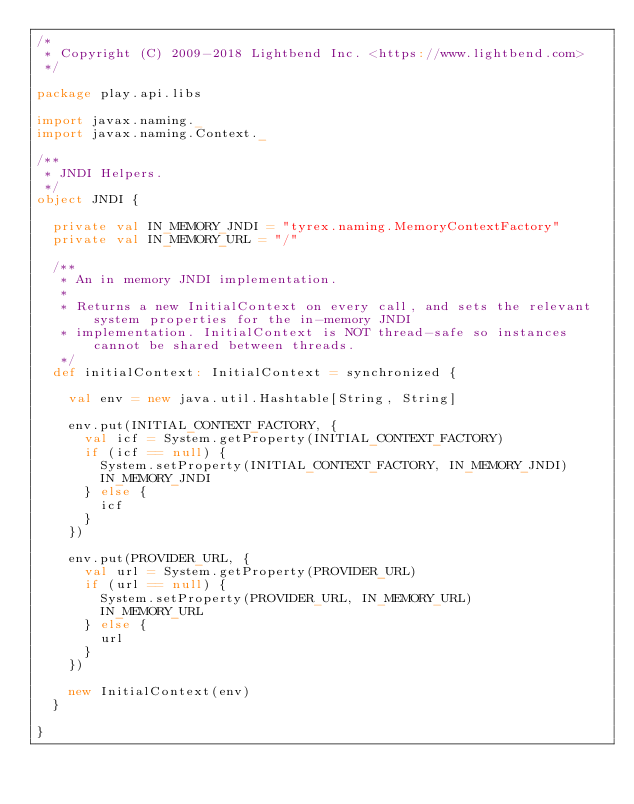<code> <loc_0><loc_0><loc_500><loc_500><_Scala_>/*
 * Copyright (C) 2009-2018 Lightbend Inc. <https://www.lightbend.com>
 */

package play.api.libs

import javax.naming._
import javax.naming.Context._

/**
 * JNDI Helpers.
 */
object JNDI {

  private val IN_MEMORY_JNDI = "tyrex.naming.MemoryContextFactory"
  private val IN_MEMORY_URL = "/"

  /**
   * An in memory JNDI implementation.
   *
   * Returns a new InitialContext on every call, and sets the relevant system properties for the in-memory JNDI
   * implementation. InitialContext is NOT thread-safe so instances cannot be shared between threads.
   */
  def initialContext: InitialContext = synchronized {

    val env = new java.util.Hashtable[String, String]

    env.put(INITIAL_CONTEXT_FACTORY, {
      val icf = System.getProperty(INITIAL_CONTEXT_FACTORY)
      if (icf == null) {
        System.setProperty(INITIAL_CONTEXT_FACTORY, IN_MEMORY_JNDI)
        IN_MEMORY_JNDI
      } else {
        icf
      }
    })

    env.put(PROVIDER_URL, {
      val url = System.getProperty(PROVIDER_URL)
      if (url == null) {
        System.setProperty(PROVIDER_URL, IN_MEMORY_URL)
        IN_MEMORY_URL
      } else {
        url
      }
    })

    new InitialContext(env)
  }

}
</code> 